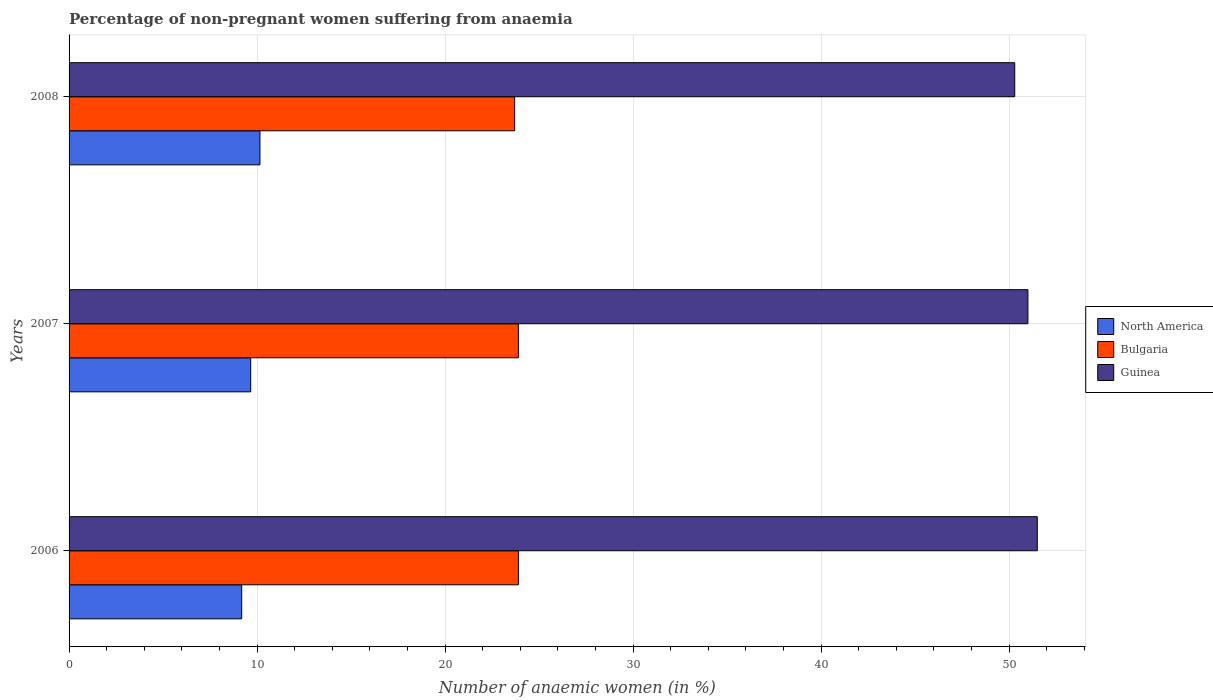How many different coloured bars are there?
Provide a short and direct response. 3. Are the number of bars per tick equal to the number of legend labels?
Make the answer very short. Yes. How many bars are there on the 3rd tick from the top?
Make the answer very short. 3. What is the percentage of non-pregnant women suffering from anaemia in Guinea in 2006?
Provide a succinct answer. 51.5. Across all years, what is the maximum percentage of non-pregnant women suffering from anaemia in North America?
Offer a very short reply. 10.15. Across all years, what is the minimum percentage of non-pregnant women suffering from anaemia in North America?
Your answer should be compact. 9.18. What is the total percentage of non-pregnant women suffering from anaemia in Guinea in the graph?
Your answer should be very brief. 152.8. What is the difference between the percentage of non-pregnant women suffering from anaemia in Guinea in 2006 and that in 2008?
Make the answer very short. 1.2. What is the difference between the percentage of non-pregnant women suffering from anaemia in Bulgaria in 2006 and the percentage of non-pregnant women suffering from anaemia in North America in 2007?
Offer a very short reply. 14.24. What is the average percentage of non-pregnant women suffering from anaemia in North America per year?
Ensure brevity in your answer.  9.67. In the year 2007, what is the difference between the percentage of non-pregnant women suffering from anaemia in Bulgaria and percentage of non-pregnant women suffering from anaemia in Guinea?
Ensure brevity in your answer.  -27.1. What is the ratio of the percentage of non-pregnant women suffering from anaemia in North America in 2007 to that in 2008?
Your answer should be very brief. 0.95. Is the percentage of non-pregnant women suffering from anaemia in Bulgaria in 2006 less than that in 2008?
Ensure brevity in your answer.  No. What is the difference between the highest and the second highest percentage of non-pregnant women suffering from anaemia in Bulgaria?
Offer a very short reply. 0. What is the difference between the highest and the lowest percentage of non-pregnant women suffering from anaemia in Guinea?
Provide a succinct answer. 1.2. In how many years, is the percentage of non-pregnant women suffering from anaemia in Guinea greater than the average percentage of non-pregnant women suffering from anaemia in Guinea taken over all years?
Offer a terse response. 2. What does the 2nd bar from the bottom in 2007 represents?
Provide a succinct answer. Bulgaria. Are all the bars in the graph horizontal?
Give a very brief answer. Yes. How many years are there in the graph?
Your answer should be compact. 3. What is the difference between two consecutive major ticks on the X-axis?
Give a very brief answer. 10. Does the graph contain any zero values?
Ensure brevity in your answer.  No. How are the legend labels stacked?
Keep it short and to the point. Vertical. What is the title of the graph?
Provide a short and direct response. Percentage of non-pregnant women suffering from anaemia. Does "High income: OECD" appear as one of the legend labels in the graph?
Your answer should be compact. No. What is the label or title of the X-axis?
Your answer should be very brief. Number of anaemic women (in %). What is the label or title of the Y-axis?
Keep it short and to the point. Years. What is the Number of anaemic women (in %) of North America in 2006?
Provide a succinct answer. 9.18. What is the Number of anaemic women (in %) of Bulgaria in 2006?
Offer a very short reply. 23.9. What is the Number of anaemic women (in %) in Guinea in 2006?
Ensure brevity in your answer.  51.5. What is the Number of anaemic women (in %) of North America in 2007?
Provide a succinct answer. 9.66. What is the Number of anaemic women (in %) in Bulgaria in 2007?
Make the answer very short. 23.9. What is the Number of anaemic women (in %) in Guinea in 2007?
Your answer should be compact. 51. What is the Number of anaemic women (in %) in North America in 2008?
Provide a short and direct response. 10.15. What is the Number of anaemic women (in %) of Bulgaria in 2008?
Give a very brief answer. 23.7. What is the Number of anaemic women (in %) in Guinea in 2008?
Keep it short and to the point. 50.3. Across all years, what is the maximum Number of anaemic women (in %) in North America?
Make the answer very short. 10.15. Across all years, what is the maximum Number of anaemic women (in %) of Bulgaria?
Ensure brevity in your answer.  23.9. Across all years, what is the maximum Number of anaemic women (in %) of Guinea?
Offer a terse response. 51.5. Across all years, what is the minimum Number of anaemic women (in %) in North America?
Your answer should be very brief. 9.18. Across all years, what is the minimum Number of anaemic women (in %) of Bulgaria?
Make the answer very short. 23.7. Across all years, what is the minimum Number of anaemic women (in %) of Guinea?
Give a very brief answer. 50.3. What is the total Number of anaemic women (in %) of North America in the graph?
Offer a terse response. 29. What is the total Number of anaemic women (in %) in Bulgaria in the graph?
Your response must be concise. 71.5. What is the total Number of anaemic women (in %) in Guinea in the graph?
Provide a short and direct response. 152.8. What is the difference between the Number of anaemic women (in %) of North America in 2006 and that in 2007?
Keep it short and to the point. -0.48. What is the difference between the Number of anaemic women (in %) in North America in 2006 and that in 2008?
Give a very brief answer. -0.97. What is the difference between the Number of anaemic women (in %) in North America in 2007 and that in 2008?
Your response must be concise. -0.49. What is the difference between the Number of anaemic women (in %) in Bulgaria in 2007 and that in 2008?
Give a very brief answer. 0.2. What is the difference between the Number of anaemic women (in %) of North America in 2006 and the Number of anaemic women (in %) of Bulgaria in 2007?
Your answer should be compact. -14.72. What is the difference between the Number of anaemic women (in %) of North America in 2006 and the Number of anaemic women (in %) of Guinea in 2007?
Make the answer very short. -41.82. What is the difference between the Number of anaemic women (in %) in Bulgaria in 2006 and the Number of anaemic women (in %) in Guinea in 2007?
Your response must be concise. -27.1. What is the difference between the Number of anaemic women (in %) of North America in 2006 and the Number of anaemic women (in %) of Bulgaria in 2008?
Offer a very short reply. -14.52. What is the difference between the Number of anaemic women (in %) in North America in 2006 and the Number of anaemic women (in %) in Guinea in 2008?
Your answer should be compact. -41.12. What is the difference between the Number of anaemic women (in %) of Bulgaria in 2006 and the Number of anaemic women (in %) of Guinea in 2008?
Give a very brief answer. -26.4. What is the difference between the Number of anaemic women (in %) of North America in 2007 and the Number of anaemic women (in %) of Bulgaria in 2008?
Offer a terse response. -14.04. What is the difference between the Number of anaemic women (in %) in North America in 2007 and the Number of anaemic women (in %) in Guinea in 2008?
Offer a terse response. -40.64. What is the difference between the Number of anaemic women (in %) in Bulgaria in 2007 and the Number of anaemic women (in %) in Guinea in 2008?
Give a very brief answer. -26.4. What is the average Number of anaemic women (in %) of North America per year?
Keep it short and to the point. 9.67. What is the average Number of anaemic women (in %) in Bulgaria per year?
Give a very brief answer. 23.83. What is the average Number of anaemic women (in %) of Guinea per year?
Your answer should be compact. 50.93. In the year 2006, what is the difference between the Number of anaemic women (in %) of North America and Number of anaemic women (in %) of Bulgaria?
Your answer should be compact. -14.72. In the year 2006, what is the difference between the Number of anaemic women (in %) of North America and Number of anaemic women (in %) of Guinea?
Ensure brevity in your answer.  -42.32. In the year 2006, what is the difference between the Number of anaemic women (in %) in Bulgaria and Number of anaemic women (in %) in Guinea?
Offer a terse response. -27.6. In the year 2007, what is the difference between the Number of anaemic women (in %) in North America and Number of anaemic women (in %) in Bulgaria?
Offer a terse response. -14.24. In the year 2007, what is the difference between the Number of anaemic women (in %) in North America and Number of anaemic women (in %) in Guinea?
Make the answer very short. -41.34. In the year 2007, what is the difference between the Number of anaemic women (in %) of Bulgaria and Number of anaemic women (in %) of Guinea?
Your response must be concise. -27.1. In the year 2008, what is the difference between the Number of anaemic women (in %) of North America and Number of anaemic women (in %) of Bulgaria?
Your answer should be very brief. -13.55. In the year 2008, what is the difference between the Number of anaemic women (in %) in North America and Number of anaemic women (in %) in Guinea?
Give a very brief answer. -40.15. In the year 2008, what is the difference between the Number of anaemic women (in %) of Bulgaria and Number of anaemic women (in %) of Guinea?
Give a very brief answer. -26.6. What is the ratio of the Number of anaemic women (in %) in North America in 2006 to that in 2007?
Offer a very short reply. 0.95. What is the ratio of the Number of anaemic women (in %) of Guinea in 2006 to that in 2007?
Your response must be concise. 1.01. What is the ratio of the Number of anaemic women (in %) in North America in 2006 to that in 2008?
Your response must be concise. 0.9. What is the ratio of the Number of anaemic women (in %) of Bulgaria in 2006 to that in 2008?
Offer a very short reply. 1.01. What is the ratio of the Number of anaemic women (in %) in Guinea in 2006 to that in 2008?
Your response must be concise. 1.02. What is the ratio of the Number of anaemic women (in %) of North America in 2007 to that in 2008?
Your response must be concise. 0.95. What is the ratio of the Number of anaemic women (in %) of Bulgaria in 2007 to that in 2008?
Offer a very short reply. 1.01. What is the ratio of the Number of anaemic women (in %) in Guinea in 2007 to that in 2008?
Give a very brief answer. 1.01. What is the difference between the highest and the second highest Number of anaemic women (in %) of North America?
Offer a terse response. 0.49. What is the difference between the highest and the second highest Number of anaemic women (in %) of Guinea?
Provide a short and direct response. 0.5. What is the difference between the highest and the lowest Number of anaemic women (in %) in North America?
Provide a short and direct response. 0.97. What is the difference between the highest and the lowest Number of anaemic women (in %) of Bulgaria?
Your response must be concise. 0.2. What is the difference between the highest and the lowest Number of anaemic women (in %) of Guinea?
Provide a succinct answer. 1.2. 